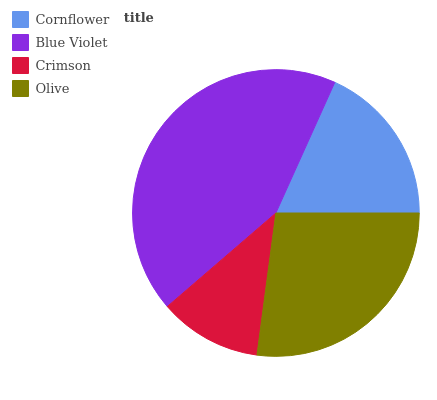Is Crimson the minimum?
Answer yes or no. Yes. Is Blue Violet the maximum?
Answer yes or no. Yes. Is Blue Violet the minimum?
Answer yes or no. No. Is Crimson the maximum?
Answer yes or no. No. Is Blue Violet greater than Crimson?
Answer yes or no. Yes. Is Crimson less than Blue Violet?
Answer yes or no. Yes. Is Crimson greater than Blue Violet?
Answer yes or no. No. Is Blue Violet less than Crimson?
Answer yes or no. No. Is Olive the high median?
Answer yes or no. Yes. Is Cornflower the low median?
Answer yes or no. Yes. Is Crimson the high median?
Answer yes or no. No. Is Olive the low median?
Answer yes or no. No. 